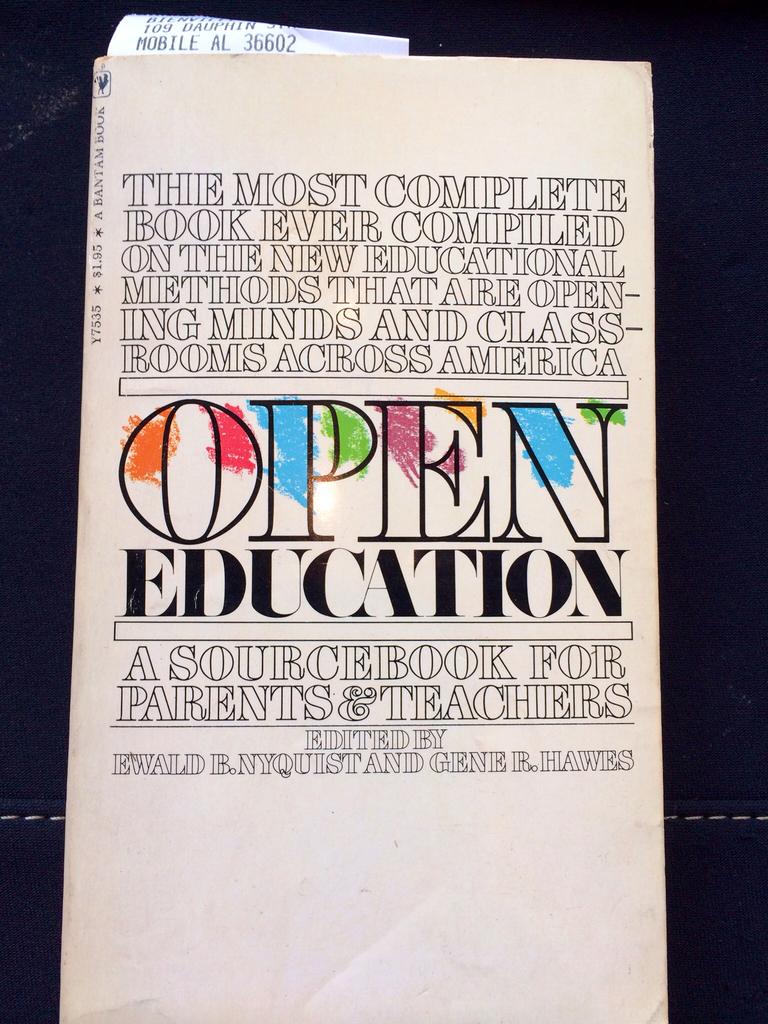What is the word that has the colorful splotches on it?
Keep it short and to the point. Open. What is the word in black below open?
Offer a very short reply. Education. 